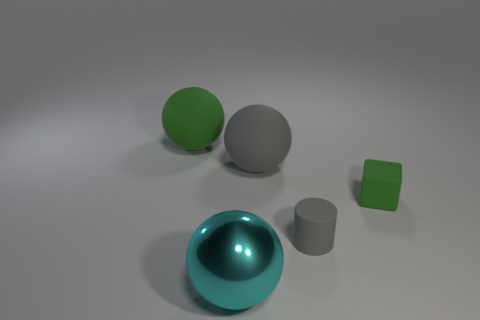How many things are gray objects that are in front of the big gray rubber sphere or big objects behind the big gray rubber thing?
Keep it short and to the point. 2. Do the small gray thing and the green object that is on the right side of the big green rubber ball have the same material?
Your answer should be very brief. Yes. How many other things are there of the same shape as the cyan object?
Offer a terse response. 2. The green object in front of the green matte object behind the tiny matte thing that is behind the cylinder is made of what material?
Provide a short and direct response. Rubber. Are there an equal number of big matte things that are right of the large gray matte ball and tiny blue rubber cylinders?
Offer a very short reply. Yes. Is the large ball in front of the matte cylinder made of the same material as the sphere on the left side of the big cyan shiny ball?
Keep it short and to the point. No. Are there any other things that are made of the same material as the large green ball?
Provide a succinct answer. Yes. There is a big rubber thing that is left of the metallic thing; does it have the same shape as the small green thing that is behind the tiny gray rubber cylinder?
Offer a terse response. No. Is the number of big rubber objects right of the green sphere less than the number of cyan shiny spheres?
Your answer should be very brief. No. What number of things are the same color as the rubber cylinder?
Provide a short and direct response. 1. 